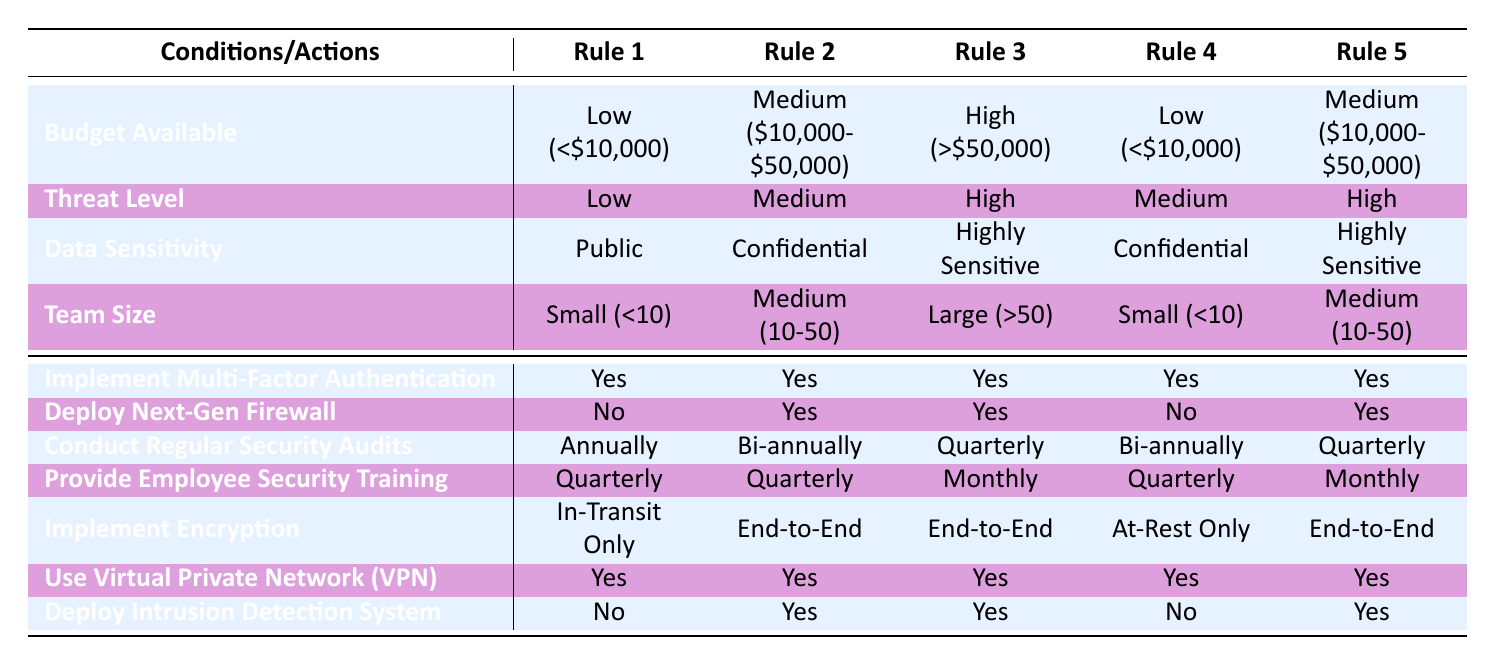What actions are taken when the budget is high and the data is highly sensitive? According to Rule 3 in the table, if the budget is high (greater than $50,000) and the data is highly sensitive, the actions implemented are: Multi-Factor Authentication (Yes), Next-Gen Firewall (Yes), Security Audits (Quarterly), Employee Security Training (Monthly), Encryption (End-to-End), VPN (Yes), and Intrusion Detection System (Yes).
Answer: Multi-Factor Authentication (Yes), Next-Gen Firewall (Yes), Security Audits (Quarterly), Employee Security Training (Monthly), Encryption (End-to-End), VPN (Yes), Intrusion Detection System (Yes) How often are security audits conducted for startups with a medium budget and medium threat level? In Rule 2, budget is medium ($10,000 to $50,000) and the threat level is medium. The table specifies that security audits are conducted bi-annually in this case.
Answer: Bi-annually Is it true that all rules recommend implementing multi-factor authentication? Upon examining all rules, it shows that multi-factor authentication is recommended in all cases across the table (Yes in all rules). Therefore, the statement is true.
Answer: Yes What are the implications for a tech startup that has a low budget and a high threat level? For a startup having a low budget (less than $10,000) and a high threat level (Rule 3 doesn't match since it has low, Rule 2 doesn't match since it's medium), it falls under Rule 4 (Low budget, Medium threat). The actions recommended are: Multi-Factor Authentication (Yes), Next-Gen Firewall (No), Security Audits (Bi-annually), Employee Security Training (Quarterly), Encryption (At-Rest Only), VPN (Yes), and Intrusion Detection System (No).
Answer: Multi-Factor Authentication (Yes), Next-Gen Firewall (No), Security Audits (Bi-annually), Employee Security Training (Quarterly), Encryption (At-Rest Only), VPN (Yes), Intrusion Detection System (No) What is the average recommended frequency for employee security training across all budget levels and threat conditions? To find the average, we will count the occurrences in the table: Quarterly (4 times), Monthly (2 times), Annually (2 times), No (0). Adding these frequencies, we get 4 (Quarterly) + 2 (Monthly) + 2 (Annually) = 8 occurrences. The average frequency is 8/5 = 1.6 which indicates closer to Quarterly training since it’s the most frequent.
Answer: Average closer to Quarterly 